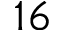Convert formula to latex. <formula><loc_0><loc_0><loc_500><loc_500>1 6</formula> 